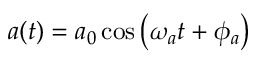Convert formula to latex. <formula><loc_0><loc_0><loc_500><loc_500>a ( t ) = a _ { 0 } \cos \left ( \omega _ { a } t + \phi _ { a } \right )</formula> 